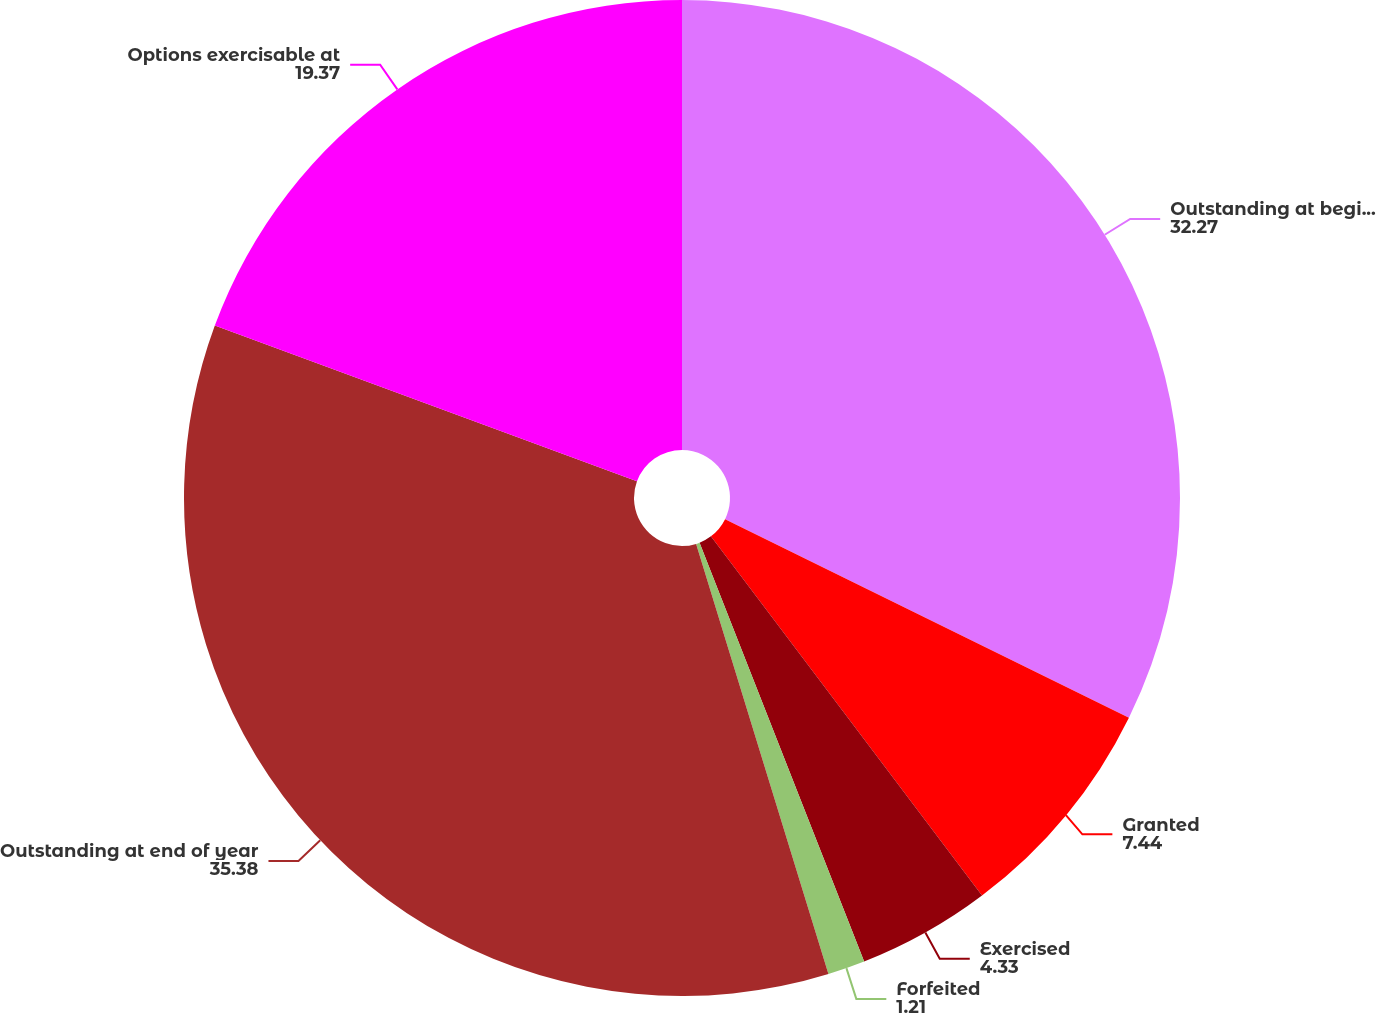Convert chart to OTSL. <chart><loc_0><loc_0><loc_500><loc_500><pie_chart><fcel>Outstanding at beginning of<fcel>Granted<fcel>Exercised<fcel>Forfeited<fcel>Outstanding at end of year<fcel>Options exercisable at<nl><fcel>32.27%<fcel>7.44%<fcel>4.33%<fcel>1.21%<fcel>35.38%<fcel>19.37%<nl></chart> 